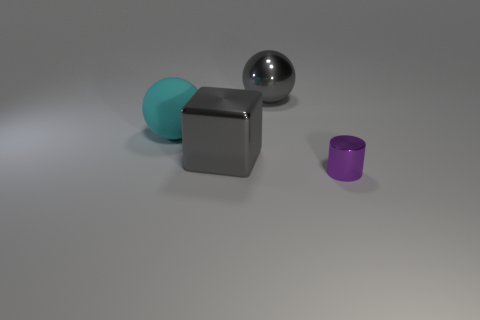Is there anything else that is the same shape as the purple object?
Provide a short and direct response. No. Is there anything else that has the same size as the purple metallic object?
Provide a succinct answer. No. There is a big gray thing that is the same material as the big gray sphere; what shape is it?
Your answer should be compact. Cube. How many large cyan balls are there?
Offer a terse response. 1. What number of objects are shiny things that are on the left side of the small object or large cyan objects?
Make the answer very short. 3. There is a large thing that is in front of the matte sphere; does it have the same color as the large metal ball?
Keep it short and to the point. Yes. What number of other objects are there of the same color as the metal cylinder?
Provide a short and direct response. 0. How many big objects are cyan matte blocks or metallic cylinders?
Offer a very short reply. 0. Is the number of gray blocks greater than the number of tiny brown matte objects?
Provide a short and direct response. Yes. Is the gray block made of the same material as the big gray ball?
Offer a terse response. Yes. 